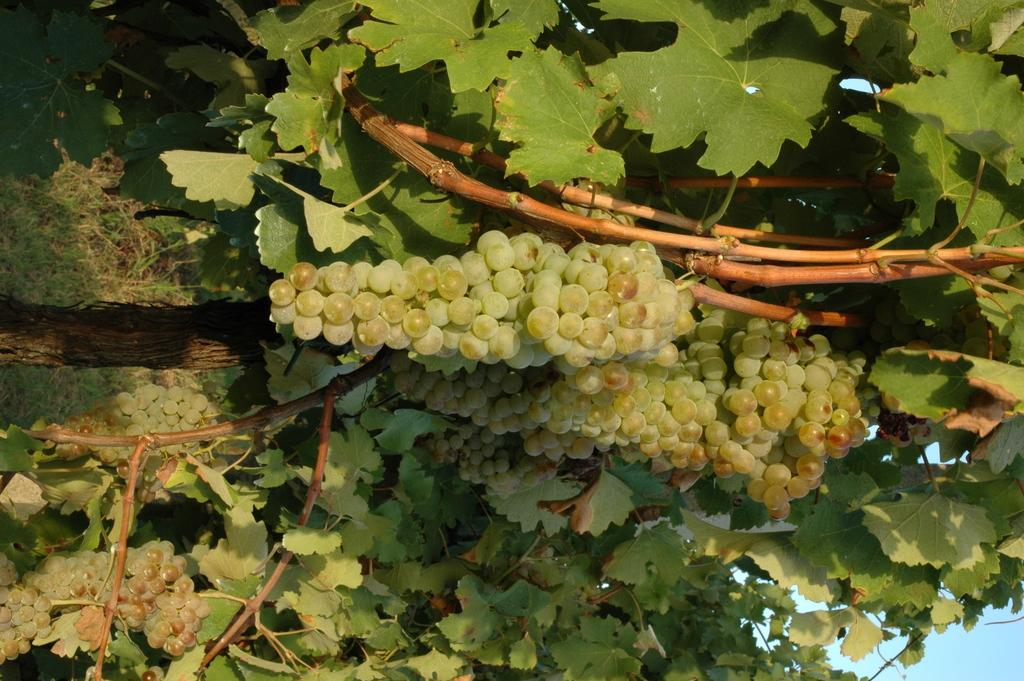What type of vegetation can be seen in the image? There are trees in the image. What is growing on the trees in the image? There are bunches of grapes visible on the trees. What part of the natural environment is visible in the image? The sky is visible in the bottom right corner of the image. What type of fuel is being used by the church in the image? There is no church present in the image, so it is not possible to determine what type of fuel might be used. 